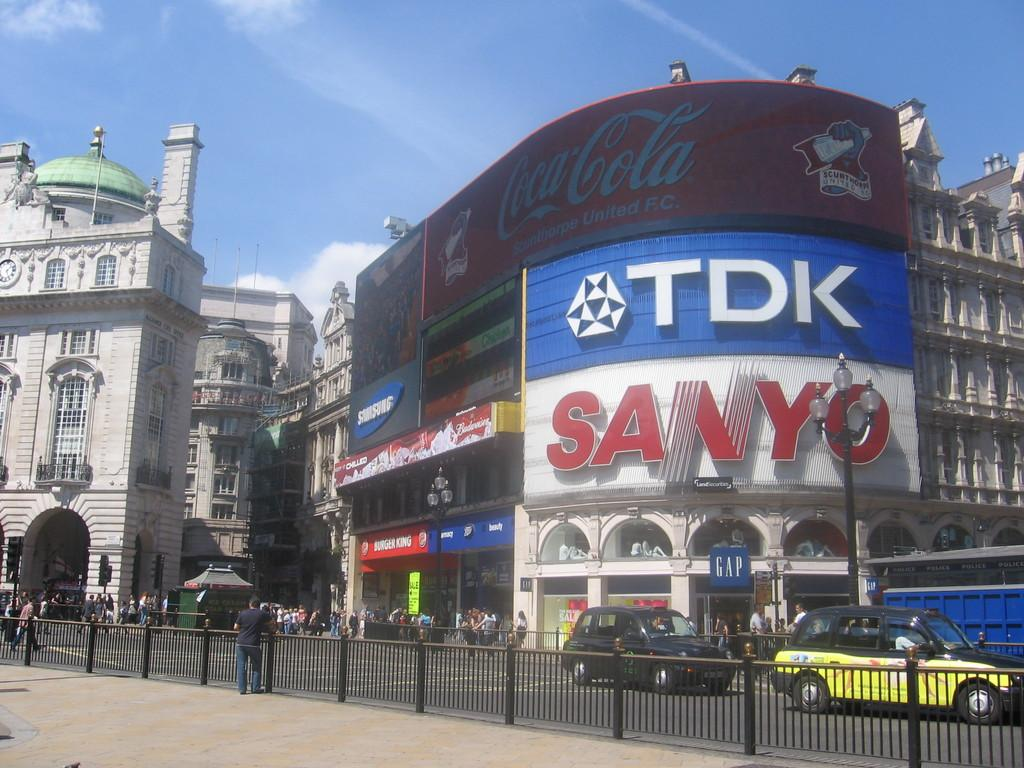<image>
Describe the image concisely. Located in a city, we see a wall full of advertisments including Coca Cola, Tdk and Sanyo, the street is busy. 